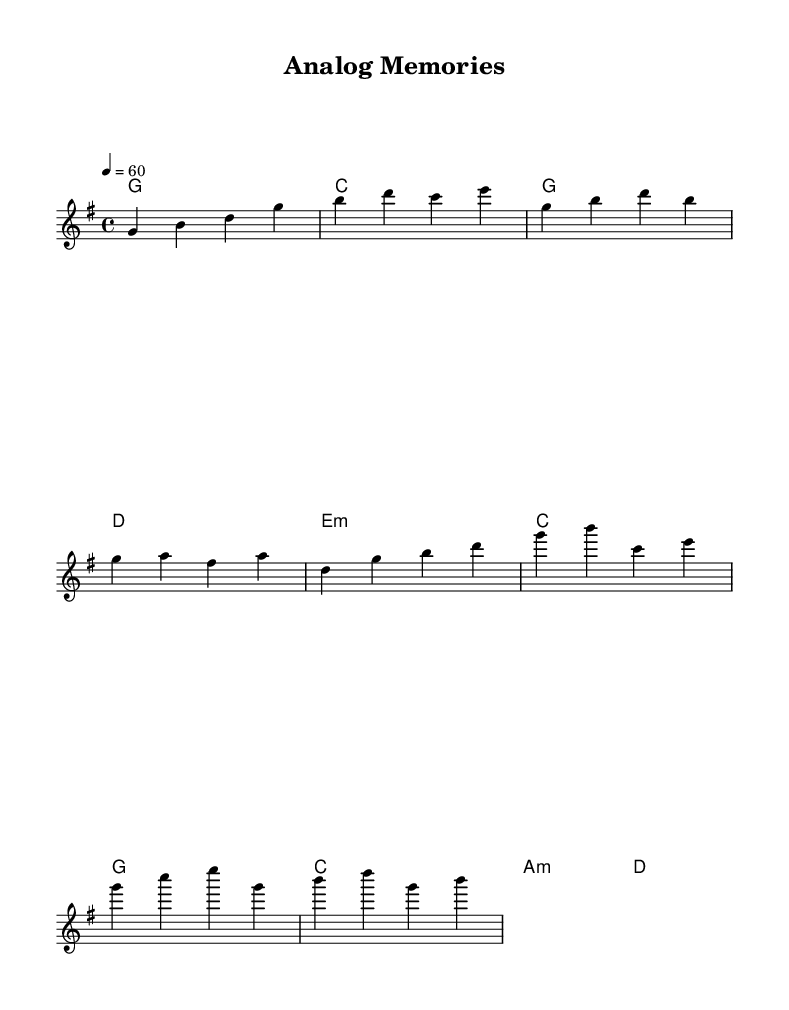What is the key signature of this music? The key signature is G major, which contains one sharp (F#). This can be determined from the beginning of the sheet music where the key signature is indicated.
Answer: G major What is the time signature of this music? The time signature is 4/4, as listed in the notation at the beginning of the piece. This means there are 4 beats in each measure, and the quarter note gets one beat.
Answer: 4/4 What is the tempo marking of the piece? The tempo marking is 60 beats per minute, specified in the tempo instruction at the beginning of the music. This indicates a relatively slow pace for the piece.
Answer: 60 How many measures are in the chorus section? The chorus section consists of 4 measures, as counted from the notation of the chorus marked in the music. By observing the grouping of notes, we can see it spans 4 distinct measures.
Answer: 4 What is the first chord of the piece? The first chord is G major, which is indicated by the chord names above the staff at the beginning of the music. It corresponds to the harmony played at the start.
Answer: G What is the structure of the song? The song has an introduction, a verse, and a chorus. This structure is deduced from the layout of the melody and harmonies, which segment clearly into these sections.
Answer: Intro, Verse, Chorus What emotional theme does the music likely evoke? The music likely evokes nostalgia for simpler times; this is inferred from the title "Analog Memories" and the style of the ballads, common in K-Pop reflecting on the past.
Answer: Nostalgia 